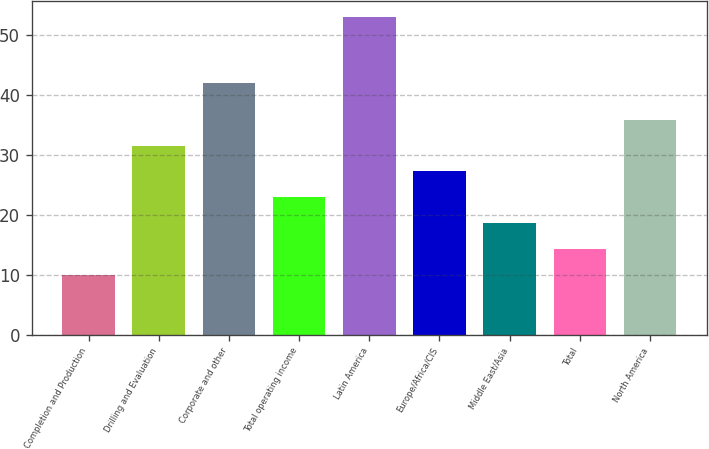Convert chart to OTSL. <chart><loc_0><loc_0><loc_500><loc_500><bar_chart><fcel>Completion and Production<fcel>Drilling and Evaluation<fcel>Corporate and other<fcel>Total operating income<fcel>Latin America<fcel>Europe/Africa/CIS<fcel>Middle East/Asia<fcel>Total<fcel>North America<nl><fcel>10<fcel>31.5<fcel>42<fcel>22.9<fcel>53<fcel>27.2<fcel>18.6<fcel>14.3<fcel>35.8<nl></chart> 